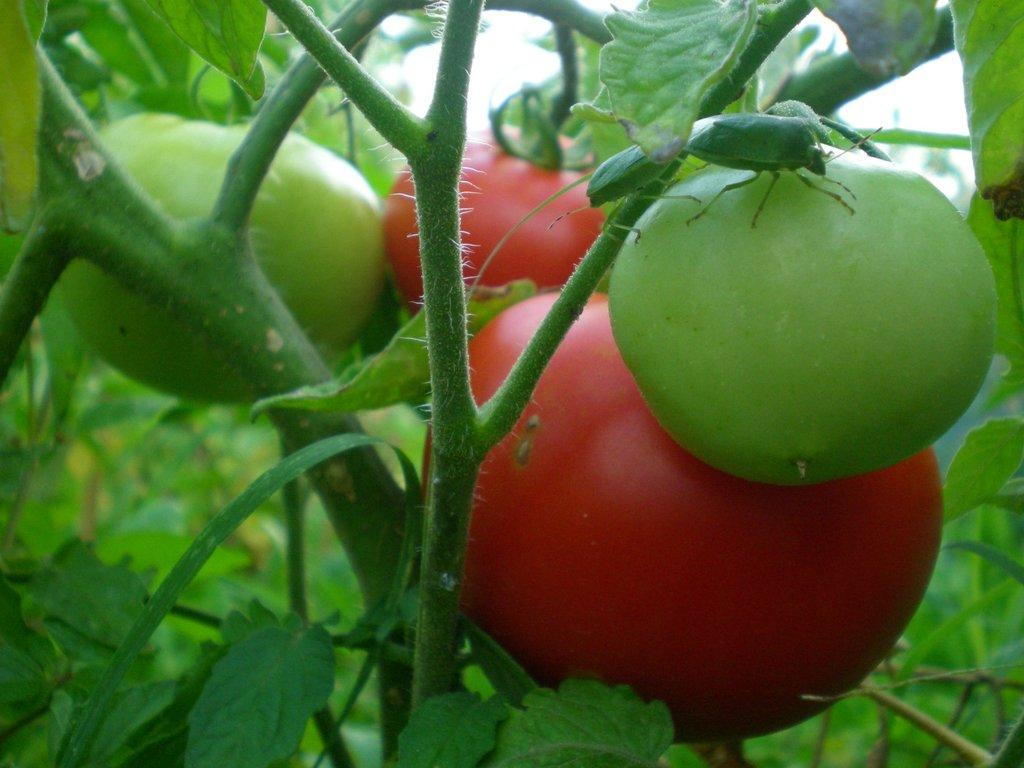What is present in the image? There is a plant in the image. What type of produce is growing on the plant? The plant has vegetables. Are there any other living organisms on the plant? Yes, there are insects on the plant. How many horses can be seen grazing near the plant in the image? There are no horses present in the image. Who is the expert on the plant's growth and care in the image? There is no expert mentioned or depicted in the image. 